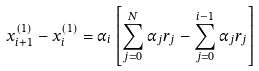Convert formula to latex. <formula><loc_0><loc_0><loc_500><loc_500>x _ { i + 1 } ^ { ( 1 ) } - x _ { i } ^ { ( 1 ) } = \alpha _ { i } \left [ \sum _ { j = 0 } ^ { N } \alpha _ { j } r _ { j } - \sum _ { j = 0 } ^ { i - 1 } \alpha _ { j } r _ { j } \right ]</formula> 